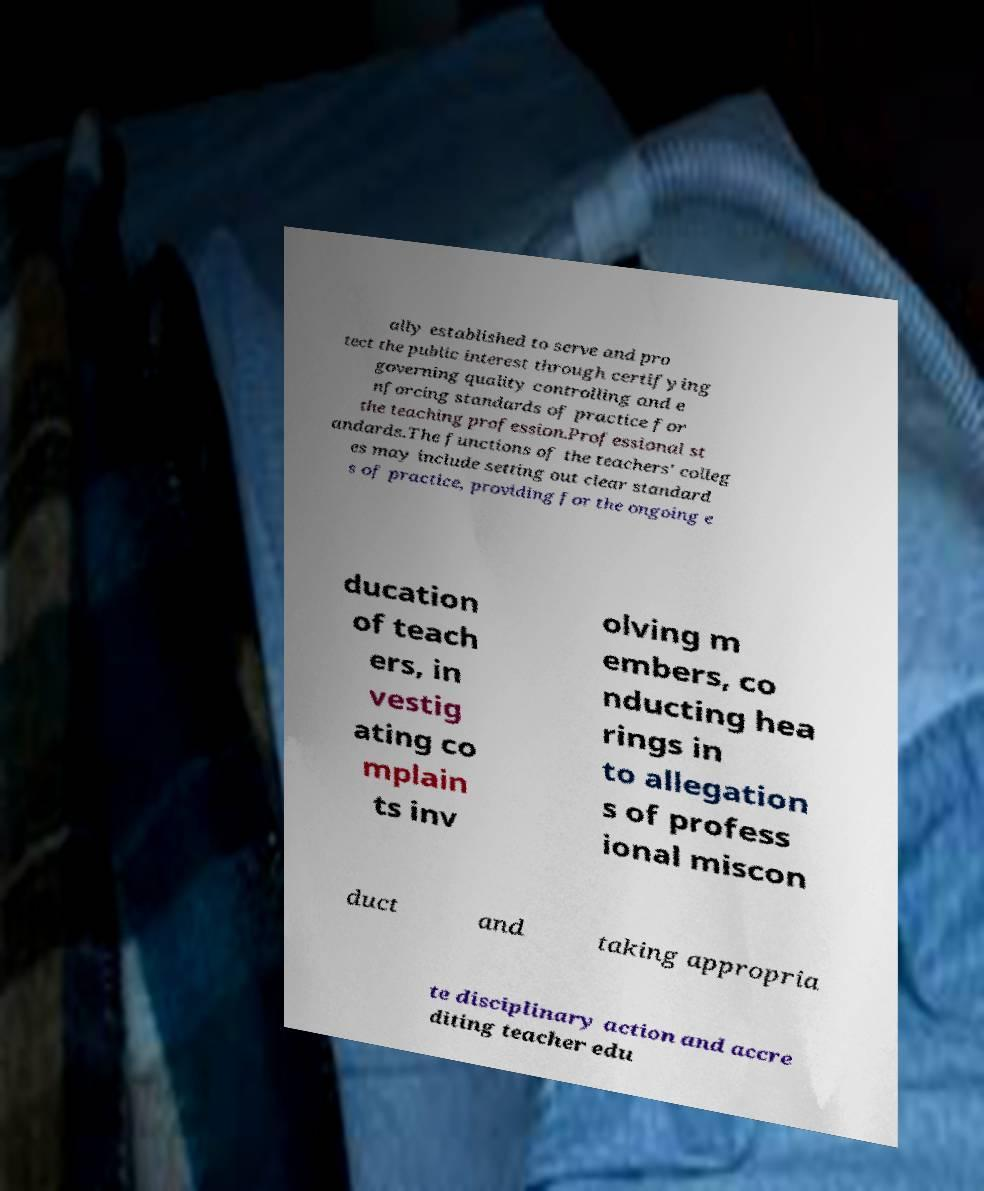For documentation purposes, I need the text within this image transcribed. Could you provide that? ally established to serve and pro tect the public interest through certifying governing quality controlling and e nforcing standards of practice for the teaching profession.Professional st andards.The functions of the teachers' colleg es may include setting out clear standard s of practice, providing for the ongoing e ducation of teach ers, in vestig ating co mplain ts inv olving m embers, co nducting hea rings in to allegation s of profess ional miscon duct and taking appropria te disciplinary action and accre diting teacher edu 